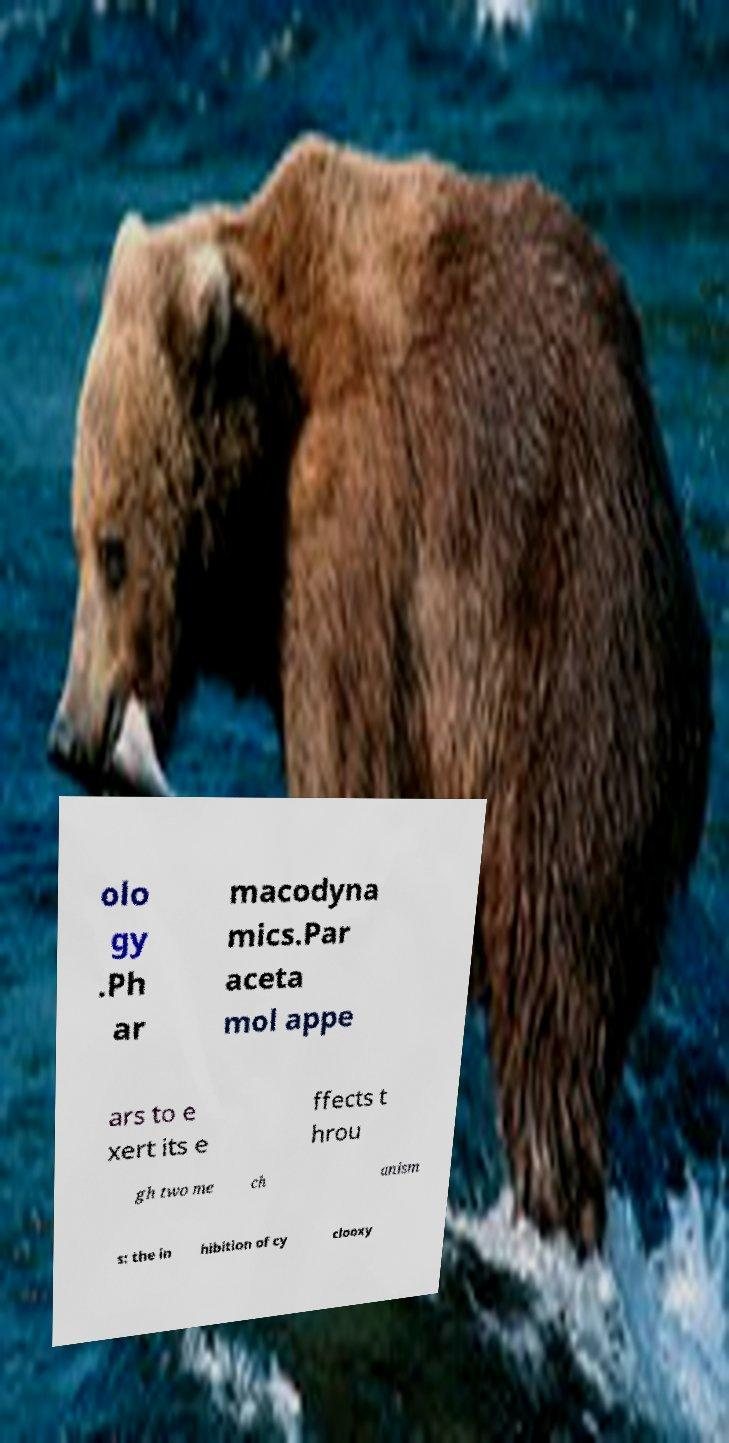There's text embedded in this image that I need extracted. Can you transcribe it verbatim? olo gy .Ph ar macodyna mics.Par aceta mol appe ars to e xert its e ffects t hrou gh two me ch anism s: the in hibition of cy clooxy 